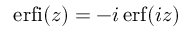<formula> <loc_0><loc_0><loc_500><loc_500>e r f i ( z ) = - i \, e r f ( i z )</formula> 